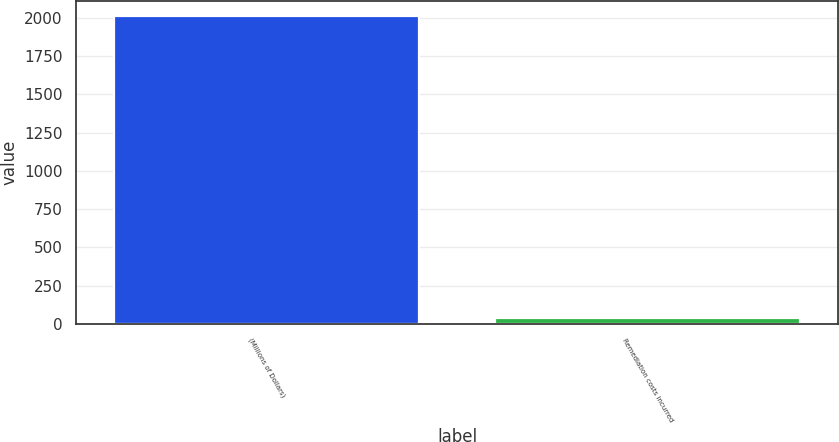Convert chart to OTSL. <chart><loc_0><loc_0><loc_500><loc_500><bar_chart><fcel>(Millions of Dollars)<fcel>Remediation costs incurred<nl><fcel>2013<fcel>35<nl></chart> 